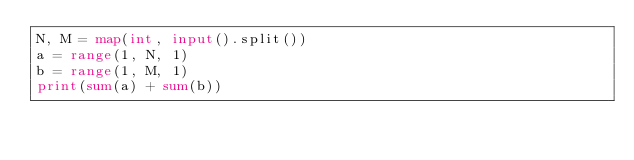<code> <loc_0><loc_0><loc_500><loc_500><_Python_>N, M = map(int, input().split())
a = range(1, N, 1)
b = range(1, M, 1)
print(sum(a) + sum(b))</code> 